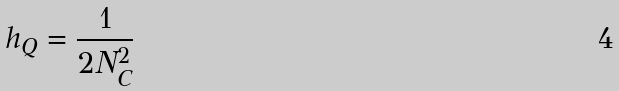Convert formula to latex. <formula><loc_0><loc_0><loc_500><loc_500>h _ { Q } = \frac { 1 } { 2 N _ { C } ^ { 2 } }</formula> 